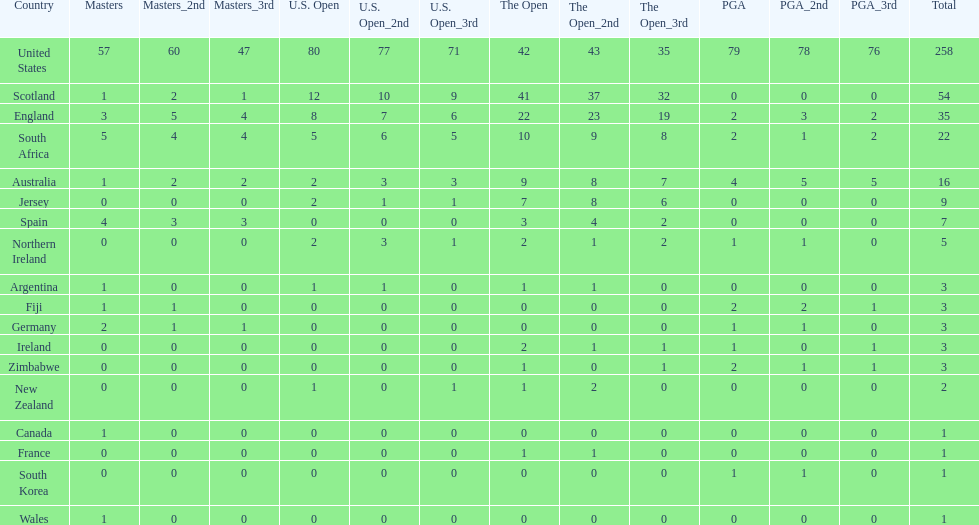How many total championships does spain have? 7. 